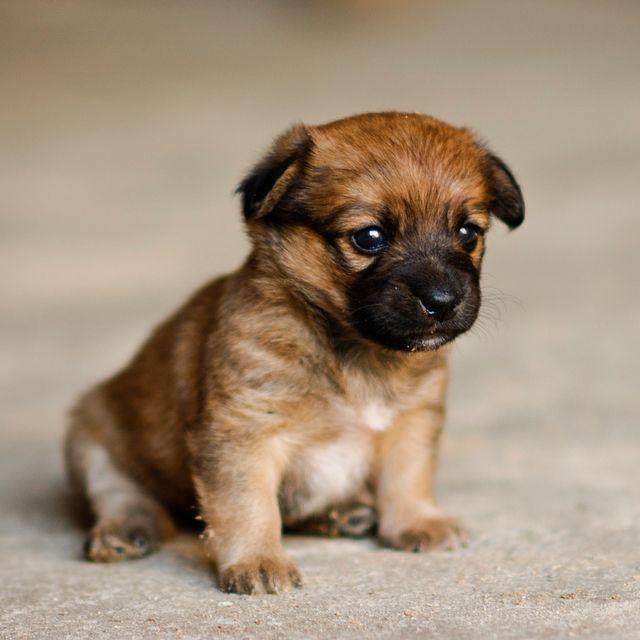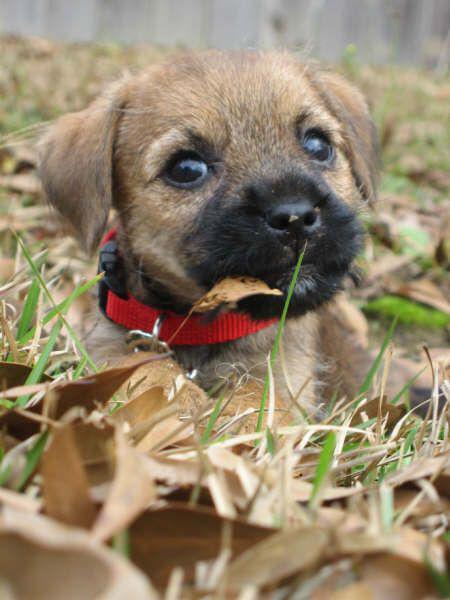The first image is the image on the left, the second image is the image on the right. For the images shown, is this caption "The dog in the image on the left has only three feet on the ground." true? Answer yes or no. No. 